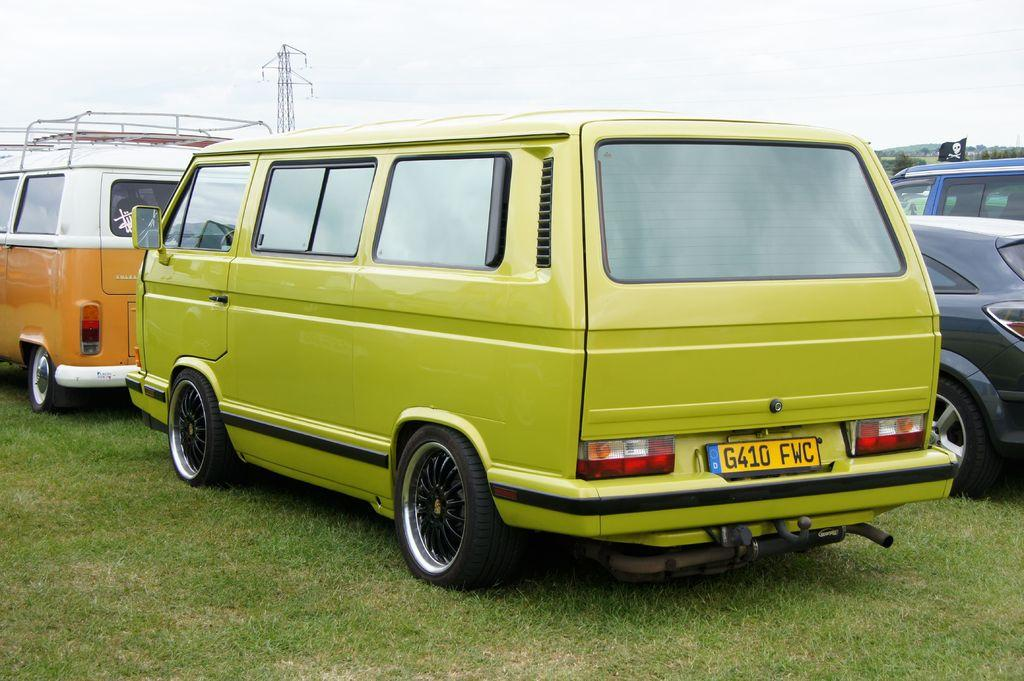<image>
Describe the image concisely. A van is parked outisde and has a license plate on it with the letter F on it. 